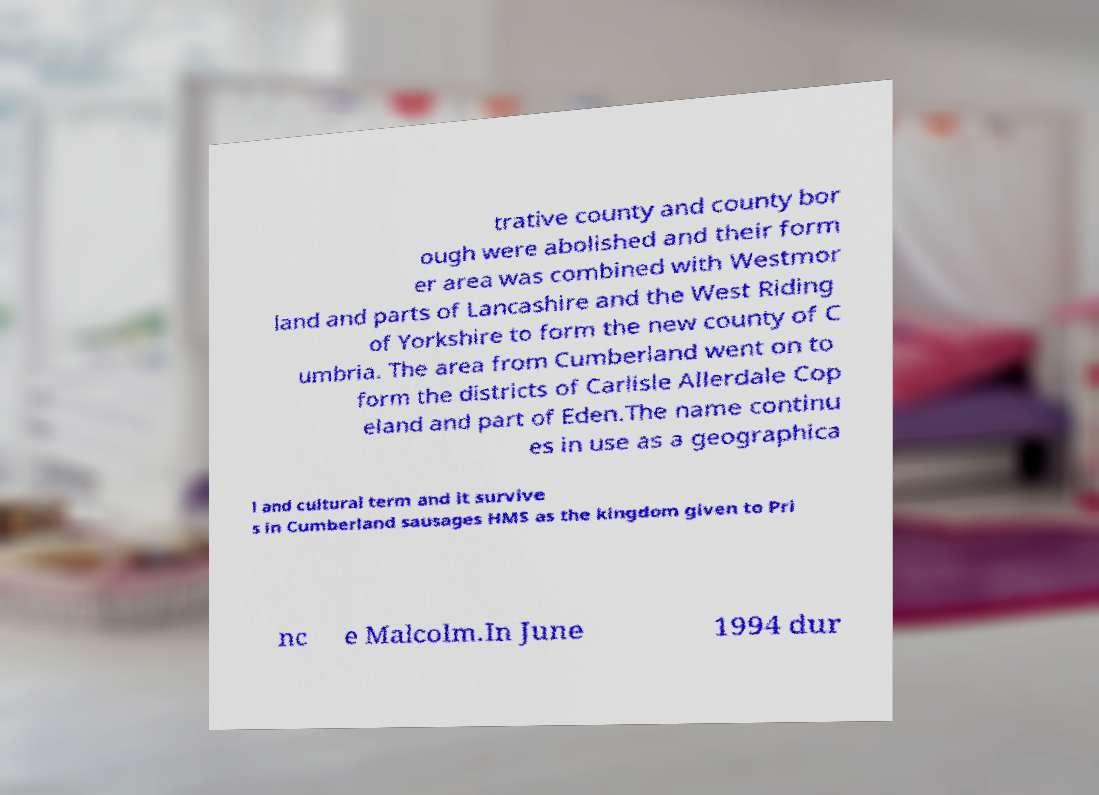There's text embedded in this image that I need extracted. Can you transcribe it verbatim? trative county and county bor ough were abolished and their form er area was combined with Westmor land and parts of Lancashire and the West Riding of Yorkshire to form the new county of C umbria. The area from Cumberland went on to form the districts of Carlisle Allerdale Cop eland and part of Eden.The name continu es in use as a geographica l and cultural term and it survive s in Cumberland sausages HMS as the kingdom given to Pri nc e Malcolm.In June 1994 dur 